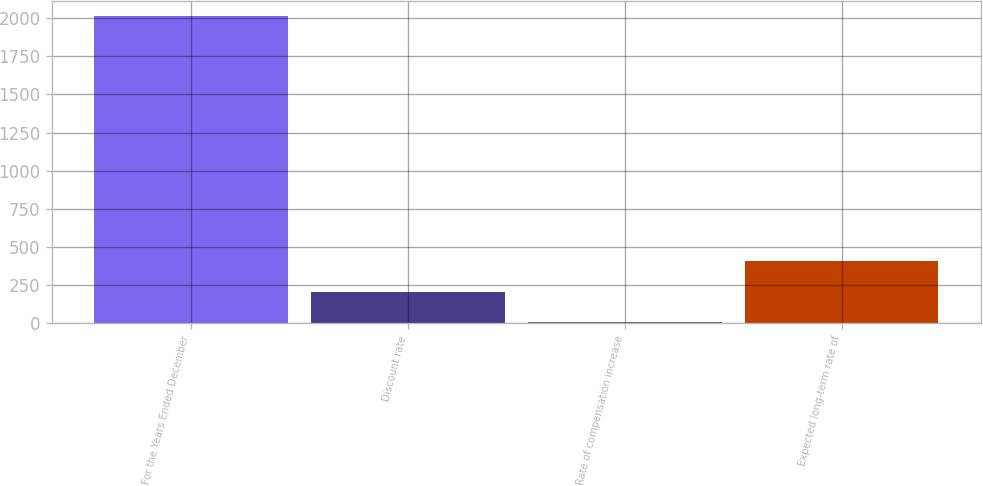Convert chart to OTSL. <chart><loc_0><loc_0><loc_500><loc_500><bar_chart><fcel>For the Years Ended December<fcel>Discount rate<fcel>Rate of compensation increase<fcel>Expected long-term rate of<nl><fcel>2014<fcel>204.36<fcel>3.29<fcel>405.43<nl></chart> 